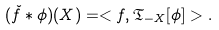<formula> <loc_0><loc_0><loc_500><loc_500>( \check { f } \ast \phi ) ( X ) = < f , \mathfrak T _ { - X } [ \phi ] > .</formula> 